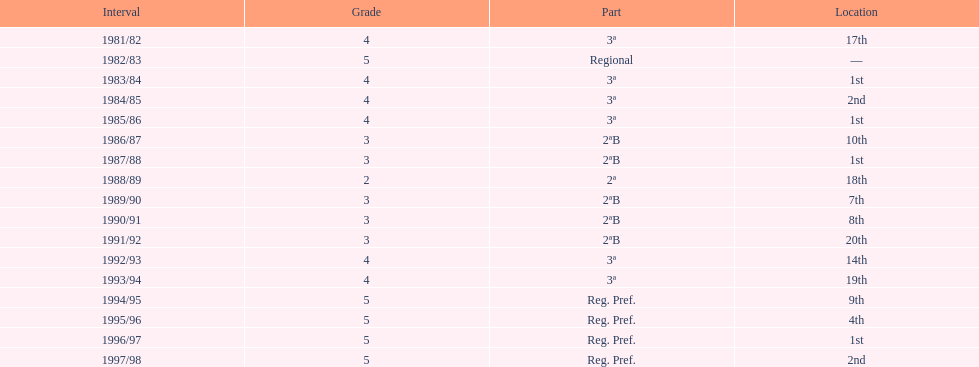For how many years did they remain in tier 3? 5. 